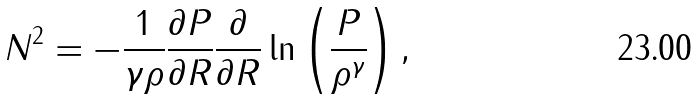<formula> <loc_0><loc_0><loc_500><loc_500>N ^ { 2 } = - \frac { 1 } { \gamma \rho } \frac { \partial P } { \partial R } \frac { \partial } { \partial R } \ln \left ( \frac { P } { \rho ^ { \gamma } } \right ) ,</formula> 